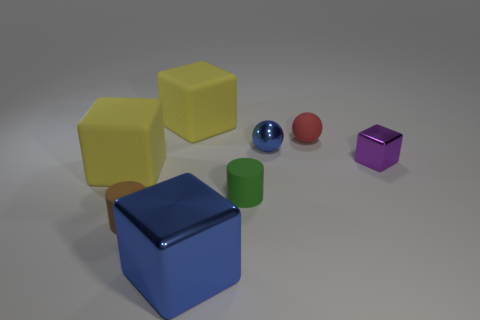How many yellow blocks must be subtracted to get 1 yellow blocks? 1 Add 1 tiny blue balls. How many objects exist? 9 Subtract all cylinders. How many objects are left? 6 Add 3 rubber spheres. How many rubber spheres are left? 4 Add 7 big metal blocks. How many big metal blocks exist? 8 Subtract 1 blue blocks. How many objects are left? 7 Subtract all cylinders. Subtract all blue metallic cubes. How many objects are left? 5 